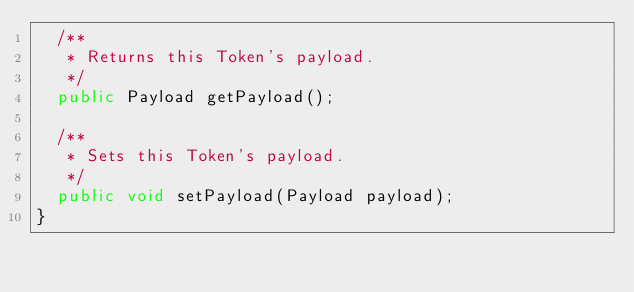Convert code to text. <code><loc_0><loc_0><loc_500><loc_500><_Java_>  /**
   * Returns this Token's payload.
   */ 
  public Payload getPayload();

  /** 
   * Sets this Token's payload.
   */
  public void setPayload(Payload payload);
}
</code> 